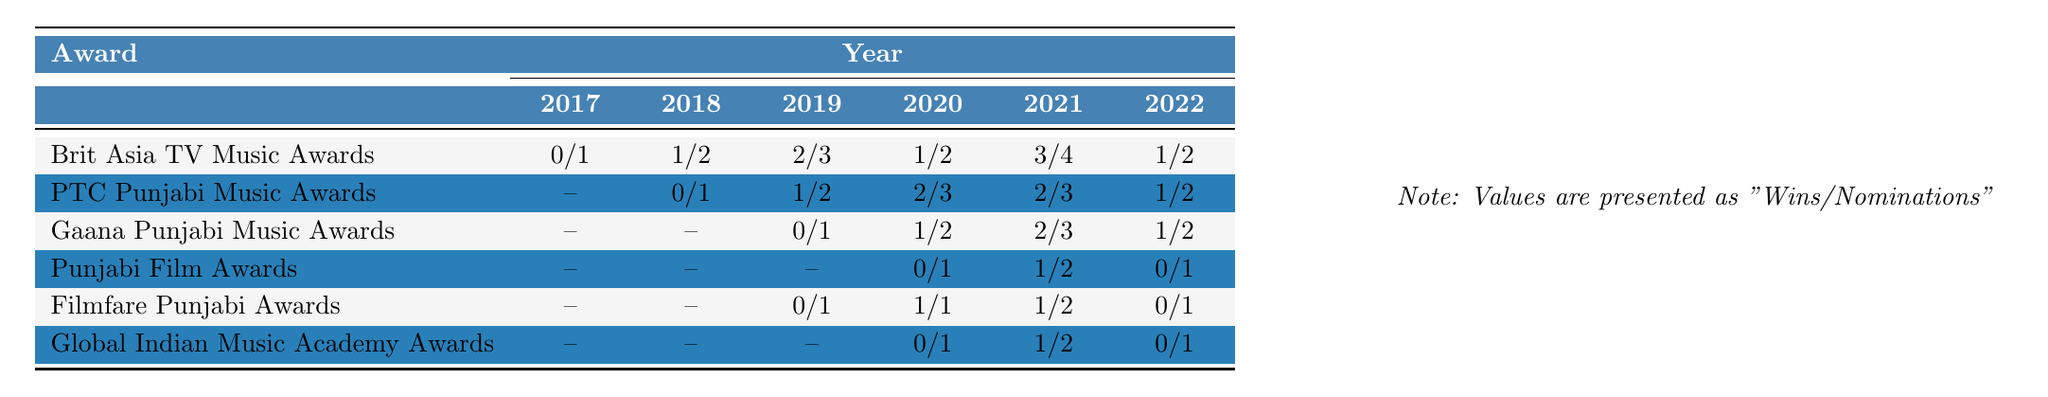What is the total number of nominations for Sidhu Moose Wala at the Brit Asia TV Music Awards from 2017 to 2022? In the table, the nominations for the Brit Asia TV Music Awards from 2017 to 2022 are 1, 2, 3, 2, 4, and 2. Adding these gives 1 + 2 + 3 + 2 + 4 + 2 = 14.
Answer: 14 Did Sidhu Moose Wala win any awards at the Punjabi Film Awards in 2022? Referring to the table, the number of wins at the Punjabi Film Awards in 2022 is listed as 0. Thus, he did not win any awards in that year.
Answer: No What was the year with the highest number of nominations for Sidhu Moose Wala at the PTC Punjabi Music Awards? Looking at the nominations for the PTC Punjabi Music Awards, the numbers by year are 0, 1, 2, 3, 3, and 2. The highest number of nominations occurred in both 2020 and 2021 with 3 nominations each.
Answer: 2020 and 2021 What is the average number of wins at the Gaana Punjabi Music Awards over the years for Sidhu Moose Wala? The wins at the Gaana Punjabi Music Awards are 0, 0, 0, 1, 2, and 1. Adding these wins: 0 + 0 + 0 + 1 + 2 + 1 = 4. Dividing by the number of years, which is 6, gives an average of 4/6 = 0.67.
Answer: 0.67 Has Sidhu Moose Wala had a consistent increase in wins at the Brit Asia TV Music Awards each year? The wins at the Brit Asia TV Music Awards are 0, 1, 2, 1, 3, and 1. Analyzing these values shows fluctuations: he had a decrease from 2 to 1 from 2019 to 2020, and again from 3 to 1 from 2021 to 2022, indicating inconsistency.
Answer: No In which award did Sidhu Moose Wala secure the least number of nominations overall from 2017 to 2022? Reviewing the nominations for all awards, the Punjabi Film Awards had a total of 4 nominations (0, 0, 0, 1, 2, 1), which is the least compared to other awards.
Answer: Punjabi Film Awards What is the difference in the number of wins at the Filmfare Punjabi Awards between 2019 and 2021? The number of wins at the Filmfare Punjabi Awards for 2019 is 0, and for 2021 it is 1. The difference is calculated as 1 - 0 = 1.
Answer: 1 What year did Sidhu Moose Wala receive the most wins combined across all awards? By summing the wins per year from all awards: 0 + 1 + 2 + 1 + 3 + 1 = 8 (2017-2022). The highest individual year is 2021 with 3 wins at the Brit Asia TV Music Awards.
Answer: 2021 